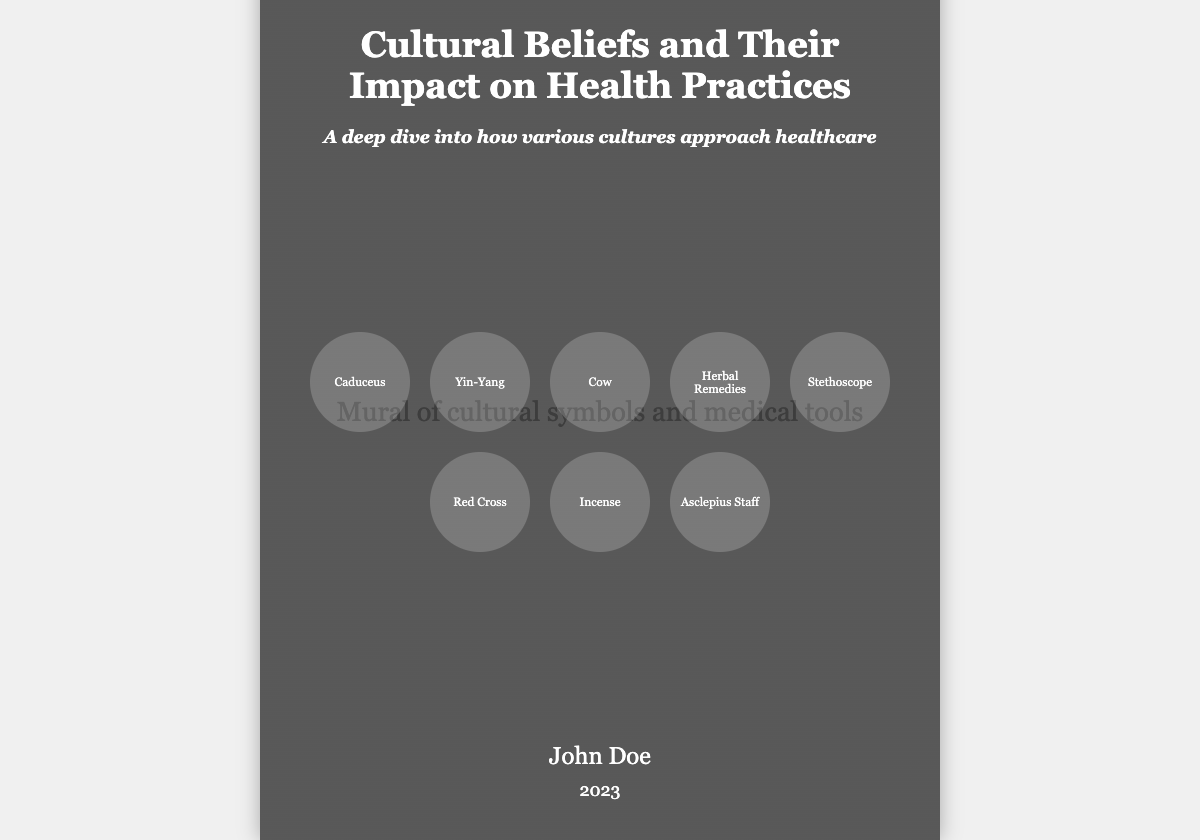What is the title of the book? The title is prominently displayed on the cover in large text.
Answer: Cultural Beliefs and Their Impact on Health Practices Who is the author of the book? The author's name is listed near the bottom of the cover.
Answer: John Doe What year was the book published? The publication year is indicated below the author's name.
Answer: 2023 What symbols are depicted on the cover? The cover includes various cultural symbols related to healthcare, illustrated as circular icons.
Answer: Caduceus, Yin-Yang, Cow, Herbal Remedies, Stethoscope, Red Cross, Incense, Asclepius Staff What is the subtitle of the book? The subtitle directly follows the title on the cover.
Answer: A deep dive into how various cultures approach healthcare How do the symbols relate to the book's topic? The symbols visually represent different cultural approaches and beliefs in healthcare practices.
Answer: Various cultural approaches to healthcare How is the background of the book cover designed? The background uses a linear gradient overlaying an image of cultural symbols and medical tools.
Answer: Linear gradient overlay with cultural symbols and medical tools What is the main focus of the book? The book aims to explore how different cultures influence health practices.
Answer: Cultural influences on health practices 